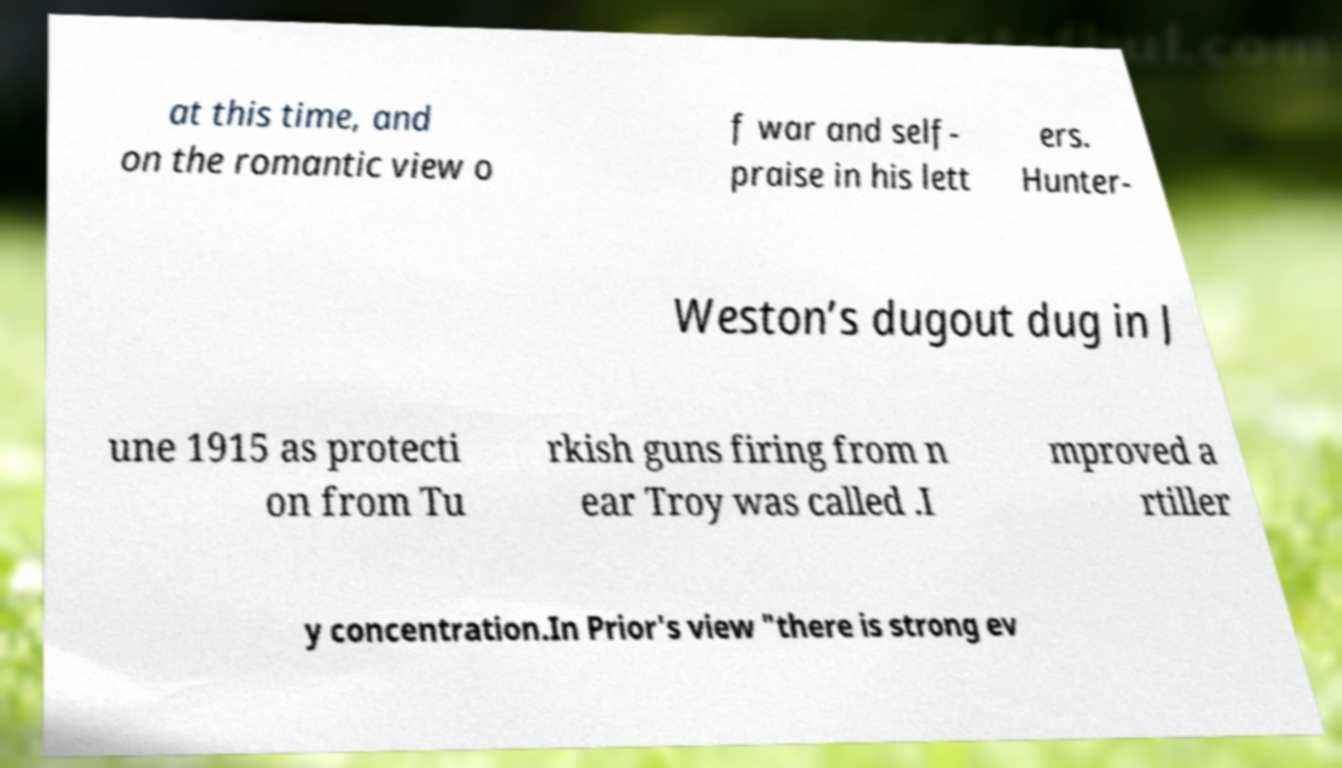Can you accurately transcribe the text from the provided image for me? at this time, and on the romantic view o f war and self- praise in his lett ers. Hunter- Weston’s dugout dug in J une 1915 as protecti on from Tu rkish guns firing from n ear Troy was called .I mproved a rtiller y concentration.In Prior's view "there is strong ev 